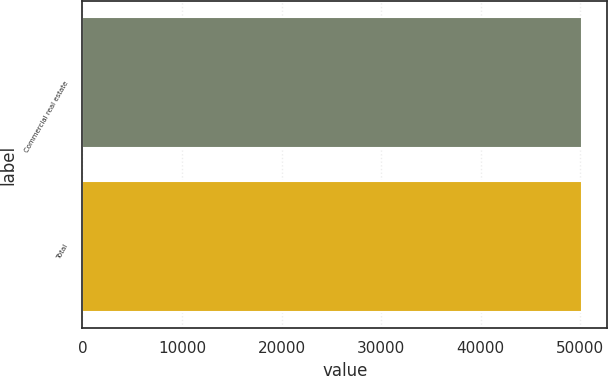Convert chart to OTSL. <chart><loc_0><loc_0><loc_500><loc_500><bar_chart><fcel>Commercial real estate<fcel>Total<nl><fcel>50175<fcel>50175.1<nl></chart> 